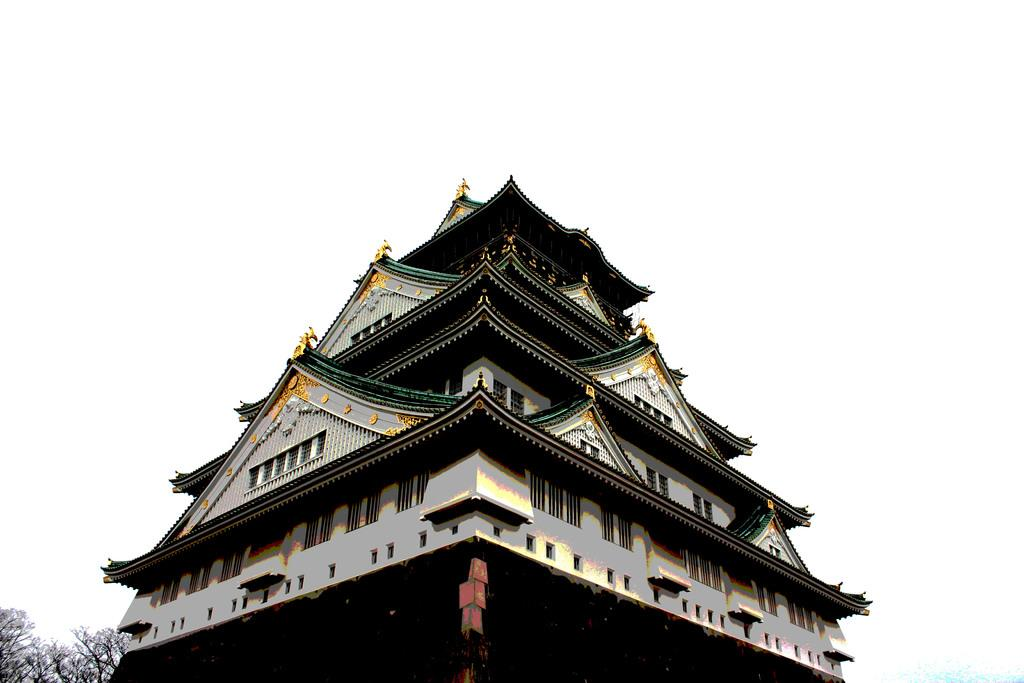What is the main subject of the image? The main subject of the image is an architecture. Where are the trees located in the image? The trees are in the bottom left of the image. What type of steel is used in the construction of the architecture in the image? There is no information about the type of steel used in the construction of the architecture in the image. Can you see the moon in the image? The moon is not visible in the image; it only features an architecture and trees. 